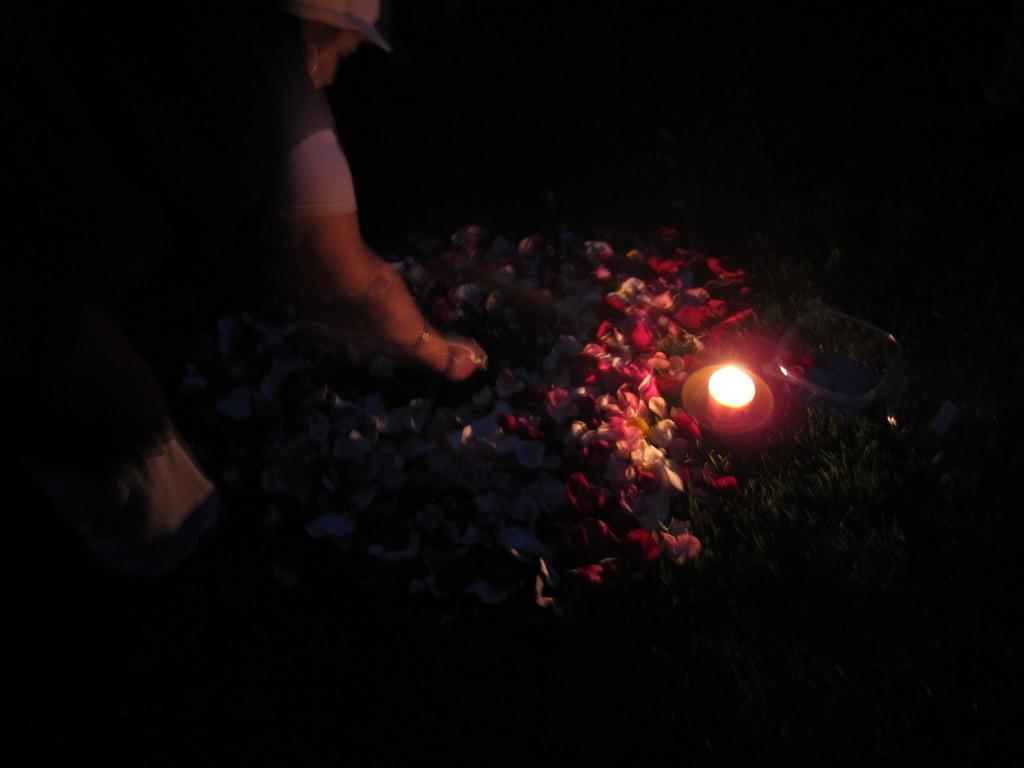Who or what is present in the image? There is a person in the image. What is the person wearing on their head? The person is wearing a hat. What type of surface is visible on the ground in the image? There is grass on the ground in the image. What type of plants can be seen in the image? There are flowers in the image. What objects are placed together in the image? There is a candle on a bowl in the image. What is the price of the act performed by the person in the image? There is no act being performed by the person in the image, and therefore no price can be determined. 